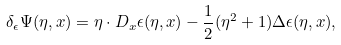Convert formula to latex. <formula><loc_0><loc_0><loc_500><loc_500>\delta _ { \epsilon } \Psi ( \eta , x ) = \eta \cdot D _ { x } \epsilon ( \eta , x ) - \frac { 1 } { 2 } ( \eta ^ { 2 } + 1 ) \Delta \epsilon ( \eta , x ) ,</formula> 